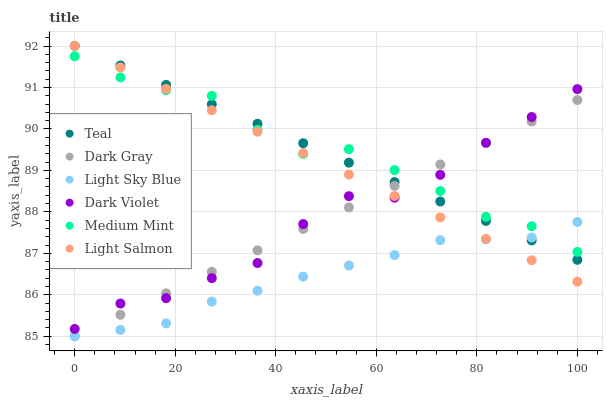Does Light Sky Blue have the minimum area under the curve?
Answer yes or no. Yes. Does Medium Mint have the maximum area under the curve?
Answer yes or no. Yes. Does Light Salmon have the minimum area under the curve?
Answer yes or no. No. Does Light Salmon have the maximum area under the curve?
Answer yes or no. No. Is Dark Gray the smoothest?
Answer yes or no. Yes. Is Medium Mint the roughest?
Answer yes or no. Yes. Is Light Salmon the smoothest?
Answer yes or no. No. Is Light Salmon the roughest?
Answer yes or no. No. Does Dark Gray have the lowest value?
Answer yes or no. Yes. Does Light Salmon have the lowest value?
Answer yes or no. No. Does Teal have the highest value?
Answer yes or no. Yes. Does Dark Violet have the highest value?
Answer yes or no. No. Is Light Sky Blue less than Dark Violet?
Answer yes or no. Yes. Is Dark Violet greater than Light Sky Blue?
Answer yes or no. Yes. Does Medium Mint intersect Dark Gray?
Answer yes or no. Yes. Is Medium Mint less than Dark Gray?
Answer yes or no. No. Is Medium Mint greater than Dark Gray?
Answer yes or no. No. Does Light Sky Blue intersect Dark Violet?
Answer yes or no. No. 